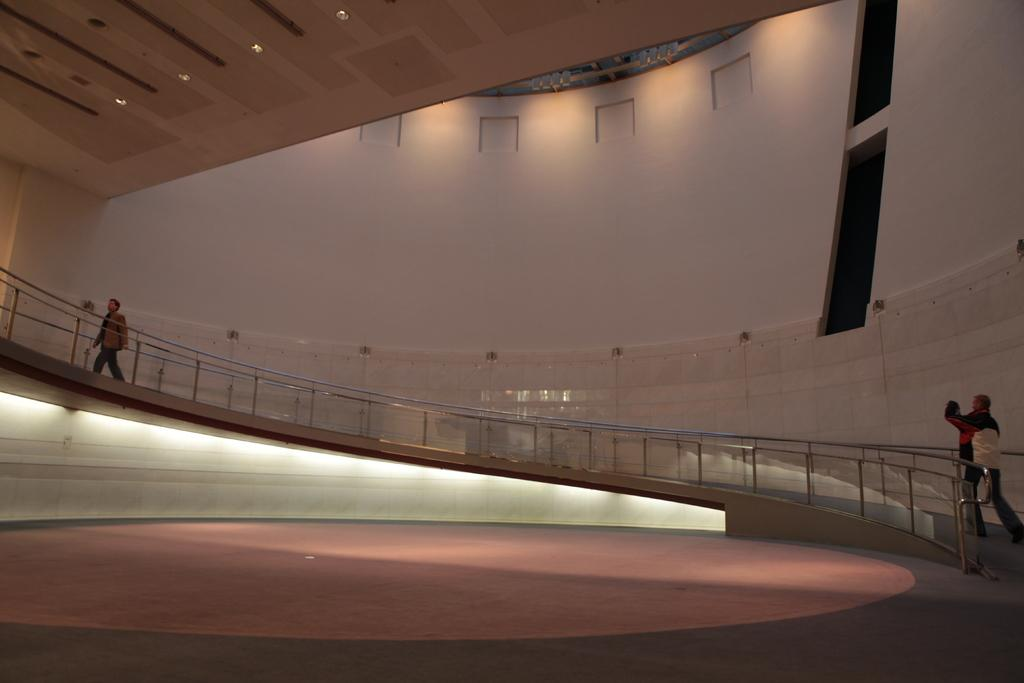What are the two persons in the image doing? The two persons in the image are walking. Can you describe the person holding an object in the image? There is a person holding an object in the image. What type of structure is visible in the image? There is a wall and a roof in the image. What can be seen illuminating the scene in the image? There are lights in the image. What type of brass instrument is being played by the person walking in the image? There is no brass instrument visible in the image, and the person holding an object is not playing any instrument. 